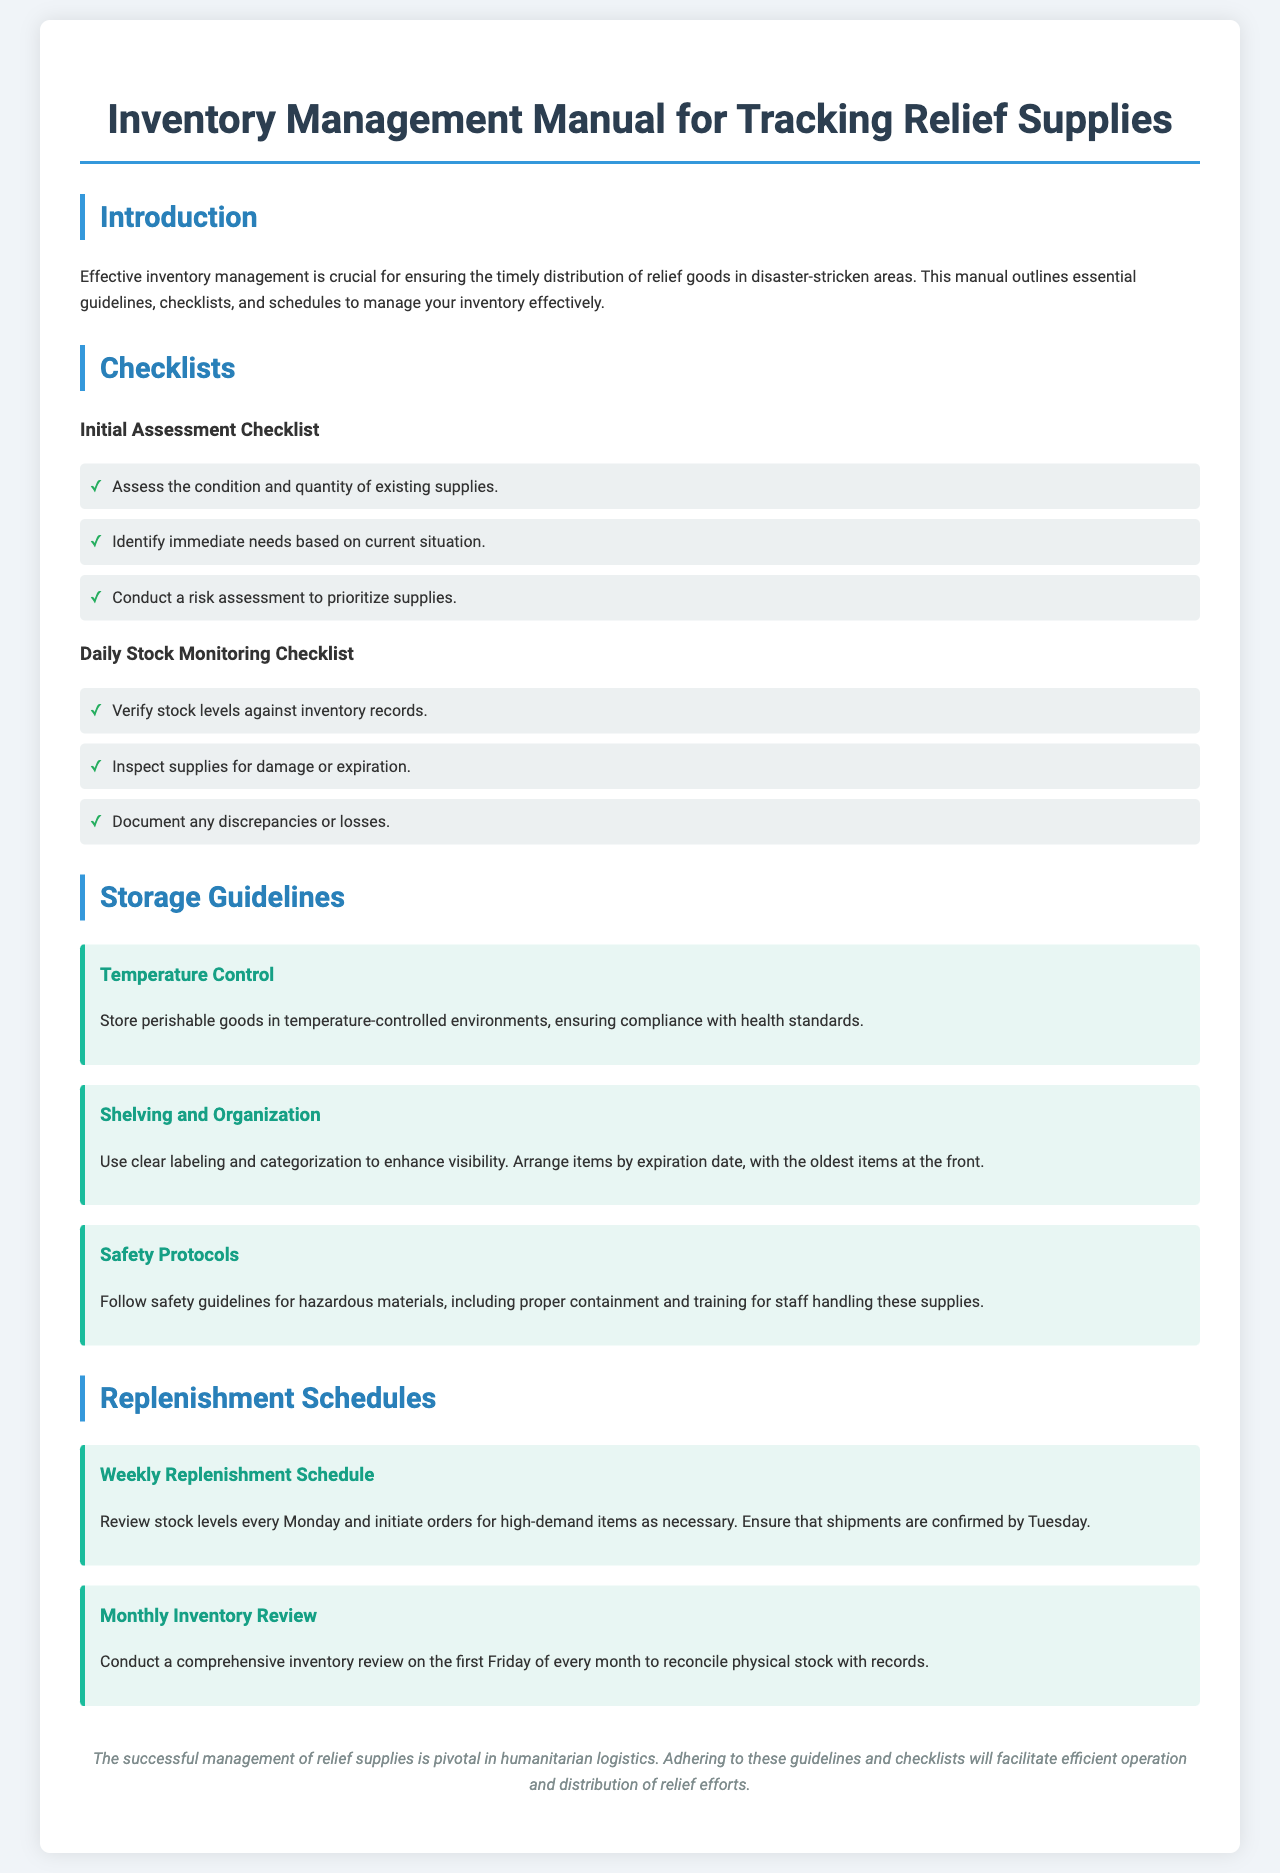What is the title of the document? The title of the document is stated in the header section, which reveals the purpose of the manual.
Answer: Inventory Management Manual for Tracking Relief Supplies How many guidelines are provided for storage? The document lists multiple guidelines in a specific section dedicated to storage, presenting them as separate points.
Answer: Three Who should conduct the monthly inventory review? The document specifies that a comprehensive inventory review occurs regularly, indicating who performs it.
Answer: Staff What day is the weekly replenishment schedule reviewed? The schedule specifies a specific day of the week for stock level reviews.
Answer: Monday What should be stored in temperature-controlled environments? The storage guidelines explicitly mention the type of goods that require specific environmental conditions for safety.
Answer: Perishable goods Which day should shipments be confirmed for the replenishment schedule? The document outlines a specific action associated with the replenishment process, indicating a timeline for clarity.
Answer: Tuesday How often should daily stock monitoring occur? The document outlines a schedule of routine checks, implying the expected frequency of this task.
Answer: Daily What is the color of the conclusion text? The document describes the text style for a specific section that summarizes the content and presents it visually.
Answer: Gray 